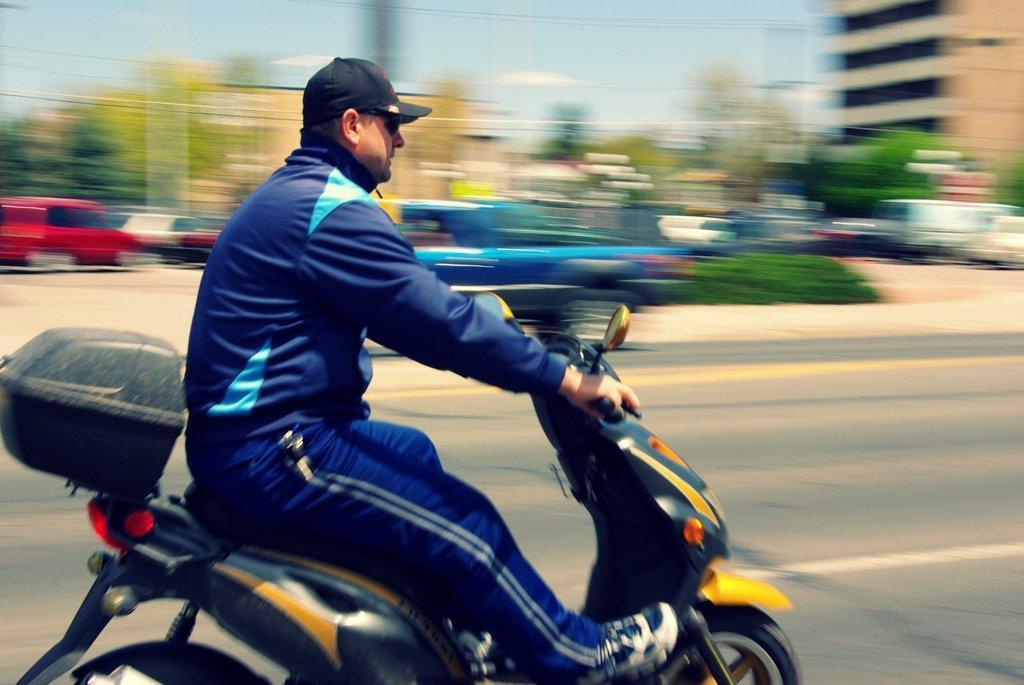In one or two sentences, can you explain what this image depicts? In this image I can see a man wearing t-shirt and black color cap on his head and also he's riding the bike on the road. In the background I can see some more vehicles are moving. On the top right of the image I can see a building. 